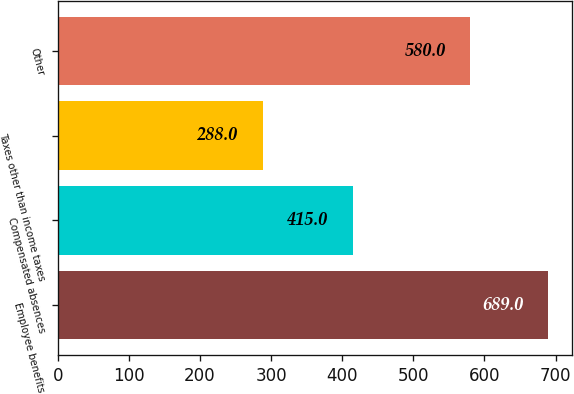<chart> <loc_0><loc_0><loc_500><loc_500><bar_chart><fcel>Employee benefits<fcel>Compensated absences<fcel>Taxes other than income taxes<fcel>Other<nl><fcel>689<fcel>415<fcel>288<fcel>580<nl></chart> 